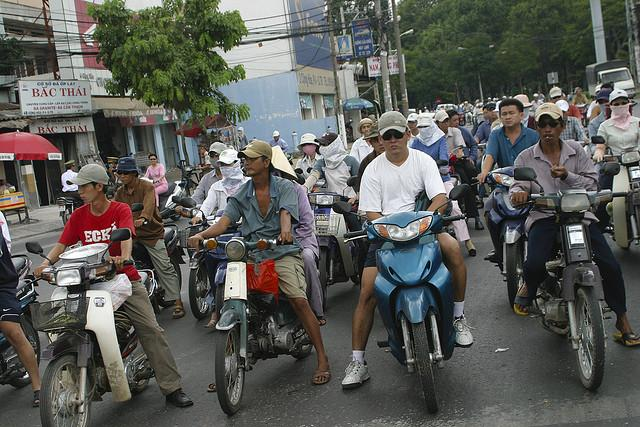What type of area is shown? street 